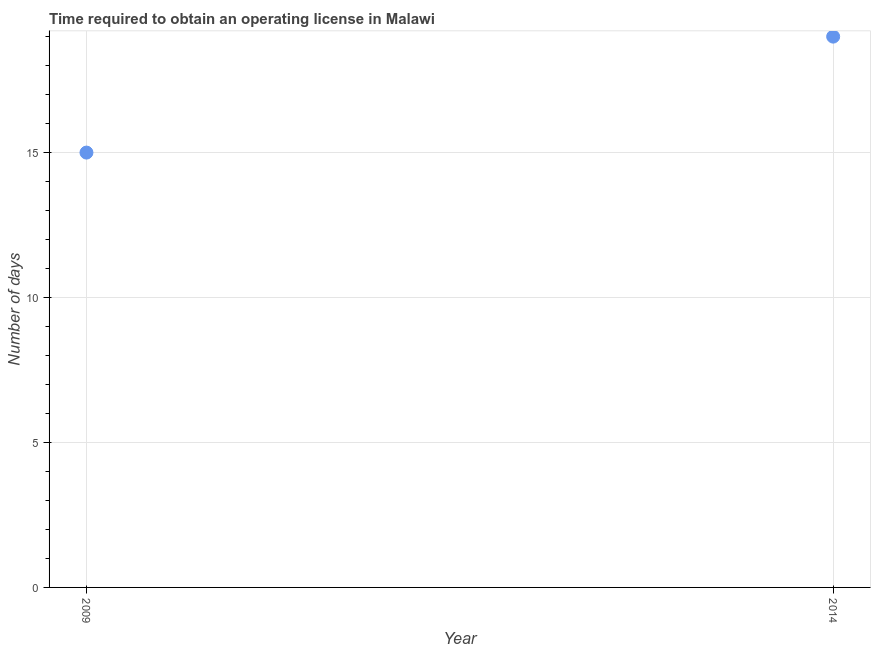What is the number of days to obtain operating license in 2009?
Give a very brief answer. 15. Across all years, what is the maximum number of days to obtain operating license?
Keep it short and to the point. 19. Across all years, what is the minimum number of days to obtain operating license?
Offer a very short reply. 15. In which year was the number of days to obtain operating license maximum?
Your response must be concise. 2014. In which year was the number of days to obtain operating license minimum?
Your answer should be compact. 2009. What is the sum of the number of days to obtain operating license?
Ensure brevity in your answer.  34. What is the difference between the number of days to obtain operating license in 2009 and 2014?
Your answer should be compact. -4. What is the average number of days to obtain operating license per year?
Keep it short and to the point. 17. What is the median number of days to obtain operating license?
Provide a succinct answer. 17. In how many years, is the number of days to obtain operating license greater than 7 days?
Give a very brief answer. 2. What is the ratio of the number of days to obtain operating license in 2009 to that in 2014?
Offer a terse response. 0.79. In how many years, is the number of days to obtain operating license greater than the average number of days to obtain operating license taken over all years?
Give a very brief answer. 1. What is the difference between two consecutive major ticks on the Y-axis?
Offer a very short reply. 5. Are the values on the major ticks of Y-axis written in scientific E-notation?
Provide a succinct answer. No. Does the graph contain any zero values?
Make the answer very short. No. Does the graph contain grids?
Provide a succinct answer. Yes. What is the title of the graph?
Make the answer very short. Time required to obtain an operating license in Malawi. What is the label or title of the Y-axis?
Your answer should be very brief. Number of days. What is the ratio of the Number of days in 2009 to that in 2014?
Give a very brief answer. 0.79. 